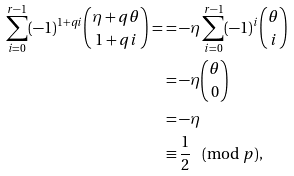<formula> <loc_0><loc_0><loc_500><loc_500>\sum _ { i = 0 } ^ { r - 1 } ( - 1 ) ^ { 1 + q i } \binom { \eta + q \theta } { 1 + q i } = & = - \eta \sum _ { i = 0 } ^ { r - 1 } ( - 1 ) ^ { i } \binom { \theta } { i } \\ & = - \eta \binom { \theta } { 0 } \\ & = - \eta \\ & \equiv \frac { 1 } { 2 } \pmod { p } ,</formula> 